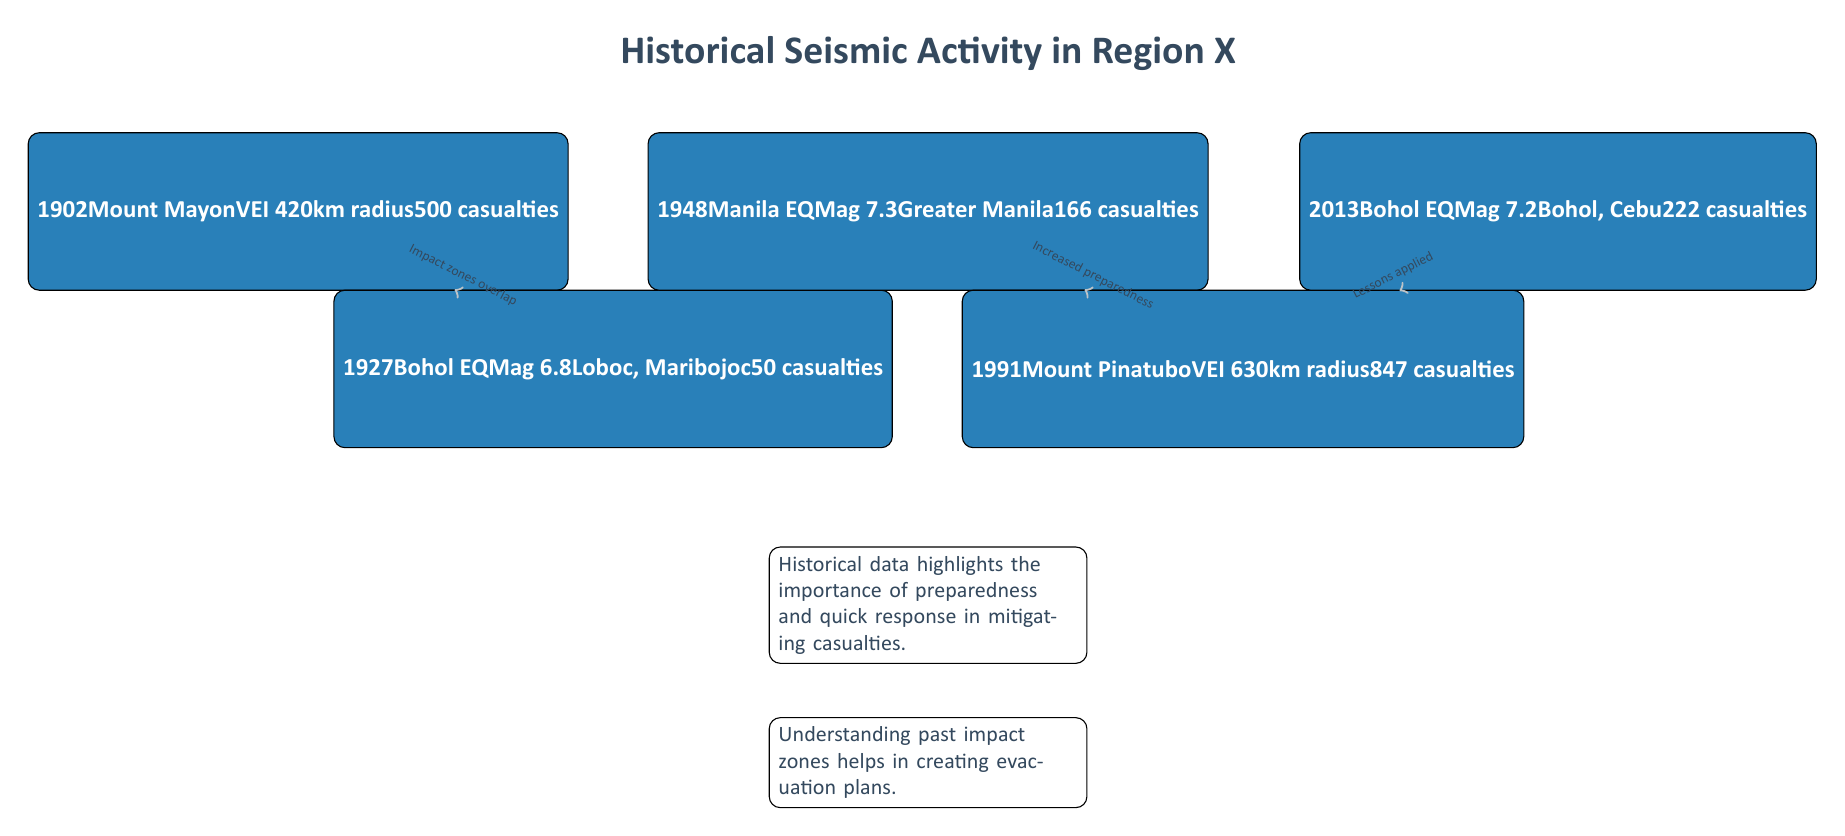What year did the Mount Pinatubo eruption occur? The diagram identifies the event node for Mount Pinatubo, which is labeled with the year 1991.
Answer: 1991 What was the magnitude of the 1948 Manila Earthquake? The magnitude of the Manila Earthquake in 1948 is specified directly in its event node as Mag 7.3.
Answer: Mag 7.3 How many casualties were reported in the 1991 Mount Pinatubo eruption? The event node for Mount Pinatubo indicates there were 847 casualties as a direct consequence of the eruption.
Answer: 847 casualties What is the relationship between the 1902 event and the 1927 event? The diagram indicates an arrow connecting the 1902 event to the 1927 event, annotated with "Impact zones overlap," suggesting a contextual relationship based on the geographical effects of these events.
Answer: Impact zones overlap What context does the diagram provide about historical data? The diagram includes context nodes that highlight the importance of preparedness and quick response to mitigate casualties as derived from historical data.
Answer: Preparedness and quick response What was the VEI level of the 1902 Mount Mayon eruption? The event node for Mount Mayon describes the Volcanic Explosivity Index (VEI) as 4 for that occurrence.
Answer: VEI 4 How many total event nodes are shown in the diagram? The diagram shows five distinct event nodes representing significant historical seismic activity events. This is counted directly from the visual representation.
Answer: 5 Which two events apply the lessons learned from prior incidents? The arrows indicate that the events in 1991 (Mount Pinatubo) and 2013 (Bohol EQ) directly relate to lessons learned, demonstrating the application of knowledge gained from historical incidents.
Answer: 1991 and 2013 What does the context node at the bottom say about understanding past impact zones? It states that understanding past impact zones is crucial for creating evacuation plans, emphasizing its importance for community safety.
Answer: Creating evacuation plans 